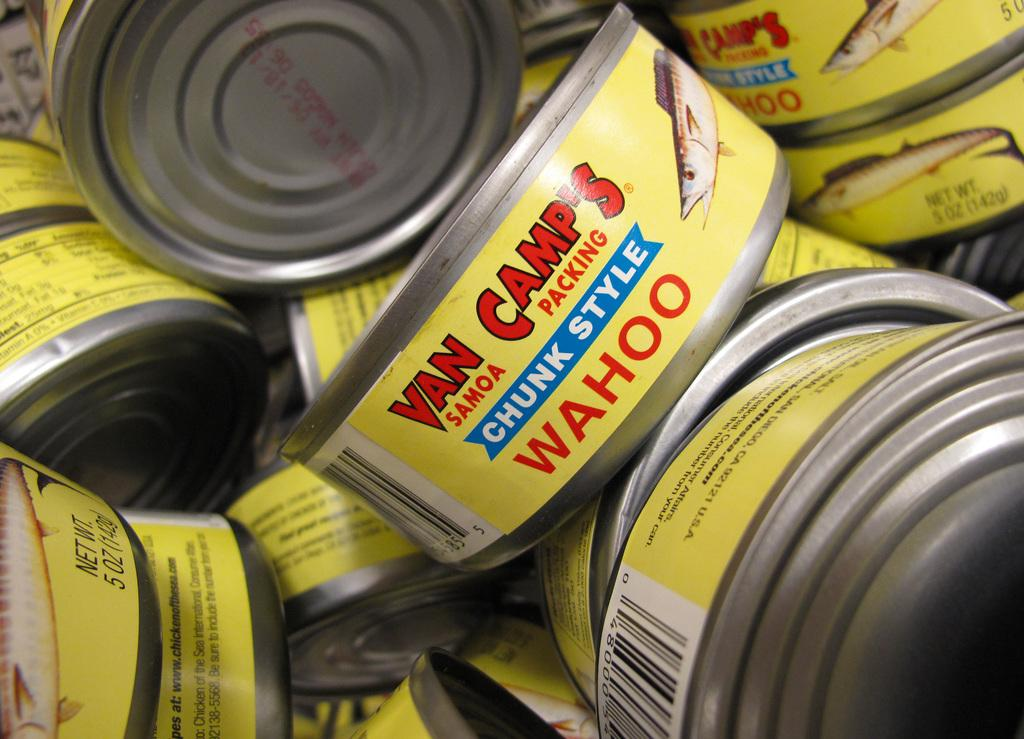<image>
Relay a brief, clear account of the picture shown. Cans of WAHOO by Van Camps Samoa Packing. 